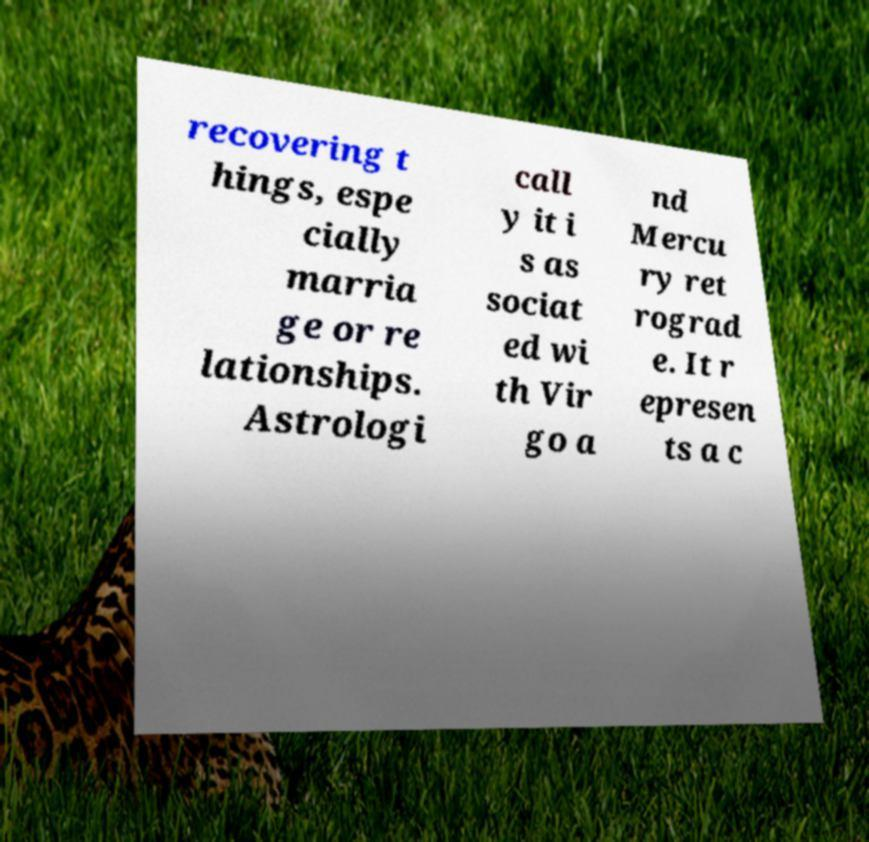Please identify and transcribe the text found in this image. recovering t hings, espe cially marria ge or re lationships. Astrologi call y it i s as sociat ed wi th Vir go a nd Mercu ry ret rograd e. It r epresen ts a c 